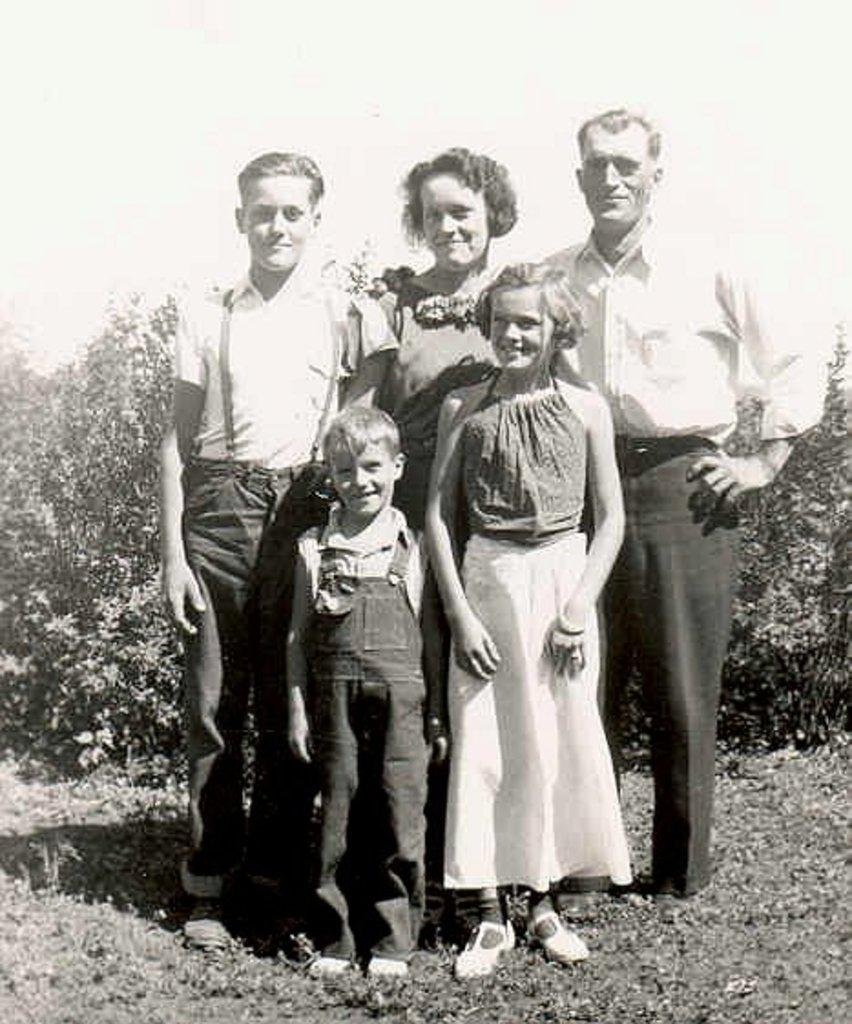What is the color scheme of the image? The image is black and white. How many people are present in the image? There are five people in the image. What are the people doing in the image? The people are standing and smiling. What type of natural environment is visible in the image? There is grass and trees visible in the image. Where are the notebooks and cows located in the image? There are no notebooks or cows present in the image. What type of building can be seen in the image? There is no building visible in the image; it features a black and white scene with five people standing and smiling amidst grass and trees. 